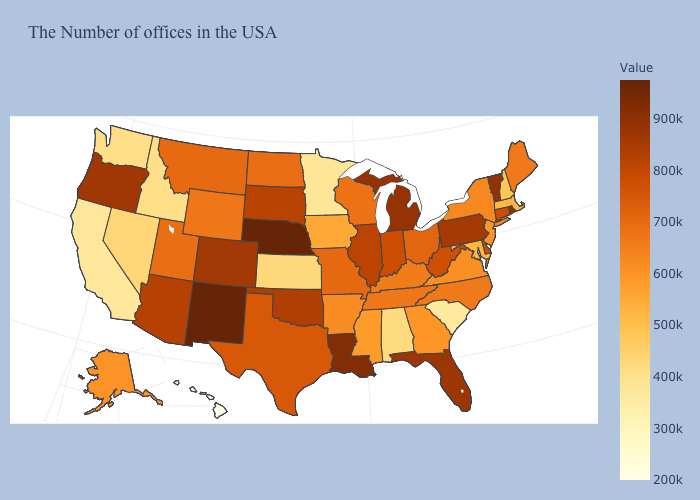Does Nebraska have the highest value in the USA?
Short answer required. Yes. Among the states that border Colorado , which have the highest value?
Quick response, please. Nebraska, New Mexico. Does North Dakota have the highest value in the MidWest?
Give a very brief answer. No. Which states have the lowest value in the USA?
Concise answer only. Hawaii. Does Oklahoma have the highest value in the USA?
Short answer required. No. Does Washington have the highest value in the USA?
Short answer required. No. 